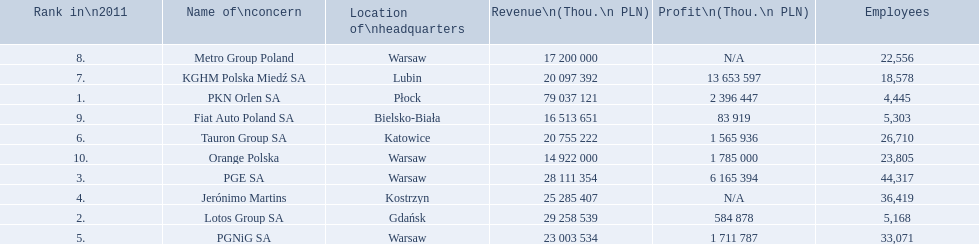What company has 28 111 354 thou.in revenue? PGE SA. What revenue does lotus group sa have? 29 258 539. Who has the next highest revenue than lotus group sa? PKN Orlen SA. 